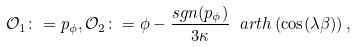Convert formula to latex. <formula><loc_0><loc_0><loc_500><loc_500>\mathcal { O } _ { 1 } \colon = p _ { \phi } , \mathcal { O } _ { 2 } \colon = \phi - \frac { s g n ( p _ { \phi } ) } { 3 \kappa } \ a r t h \left ( \cos ( \lambda \beta ) \right ) ,</formula> 